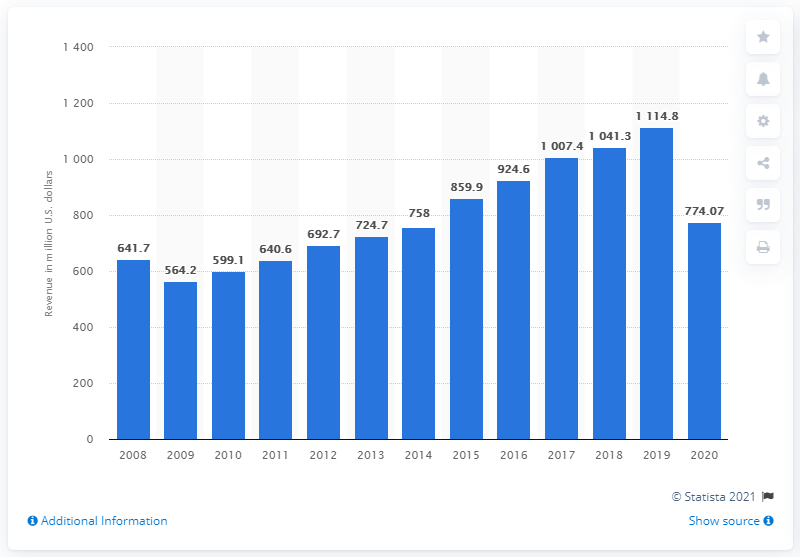Point out several critical features in this image. Choice Hotels International Inc. reported a revenue of 774.07 during the 2020 financial year. 